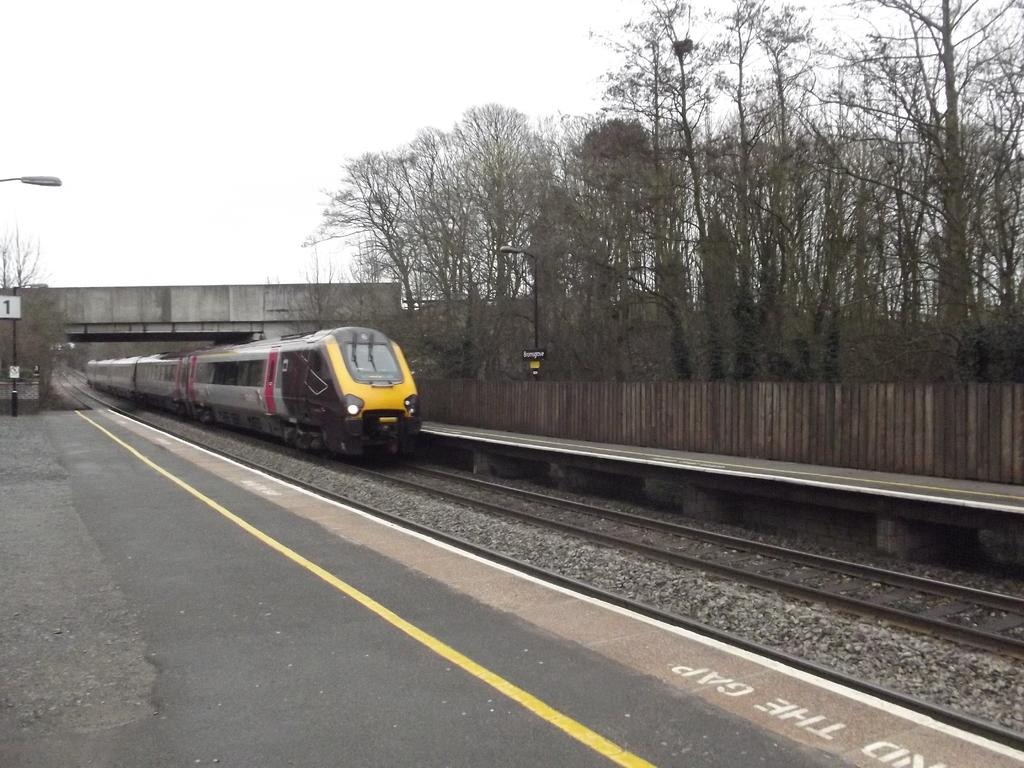What is the main subject of the image? The main subject of the image is a train. Where is the train located? The train is on a railway track. What can be seen on either side of the track? There are railway platforms on either side of the track. What type of vegetation is near the railway platforms? Trees are present near the railway platforms. How many cents are visible on the train in the image? There are no cents visible on the train in the image. What type of reward is being given to the passengers on the train? There is no indication of any reward being given to passengers in the image. 